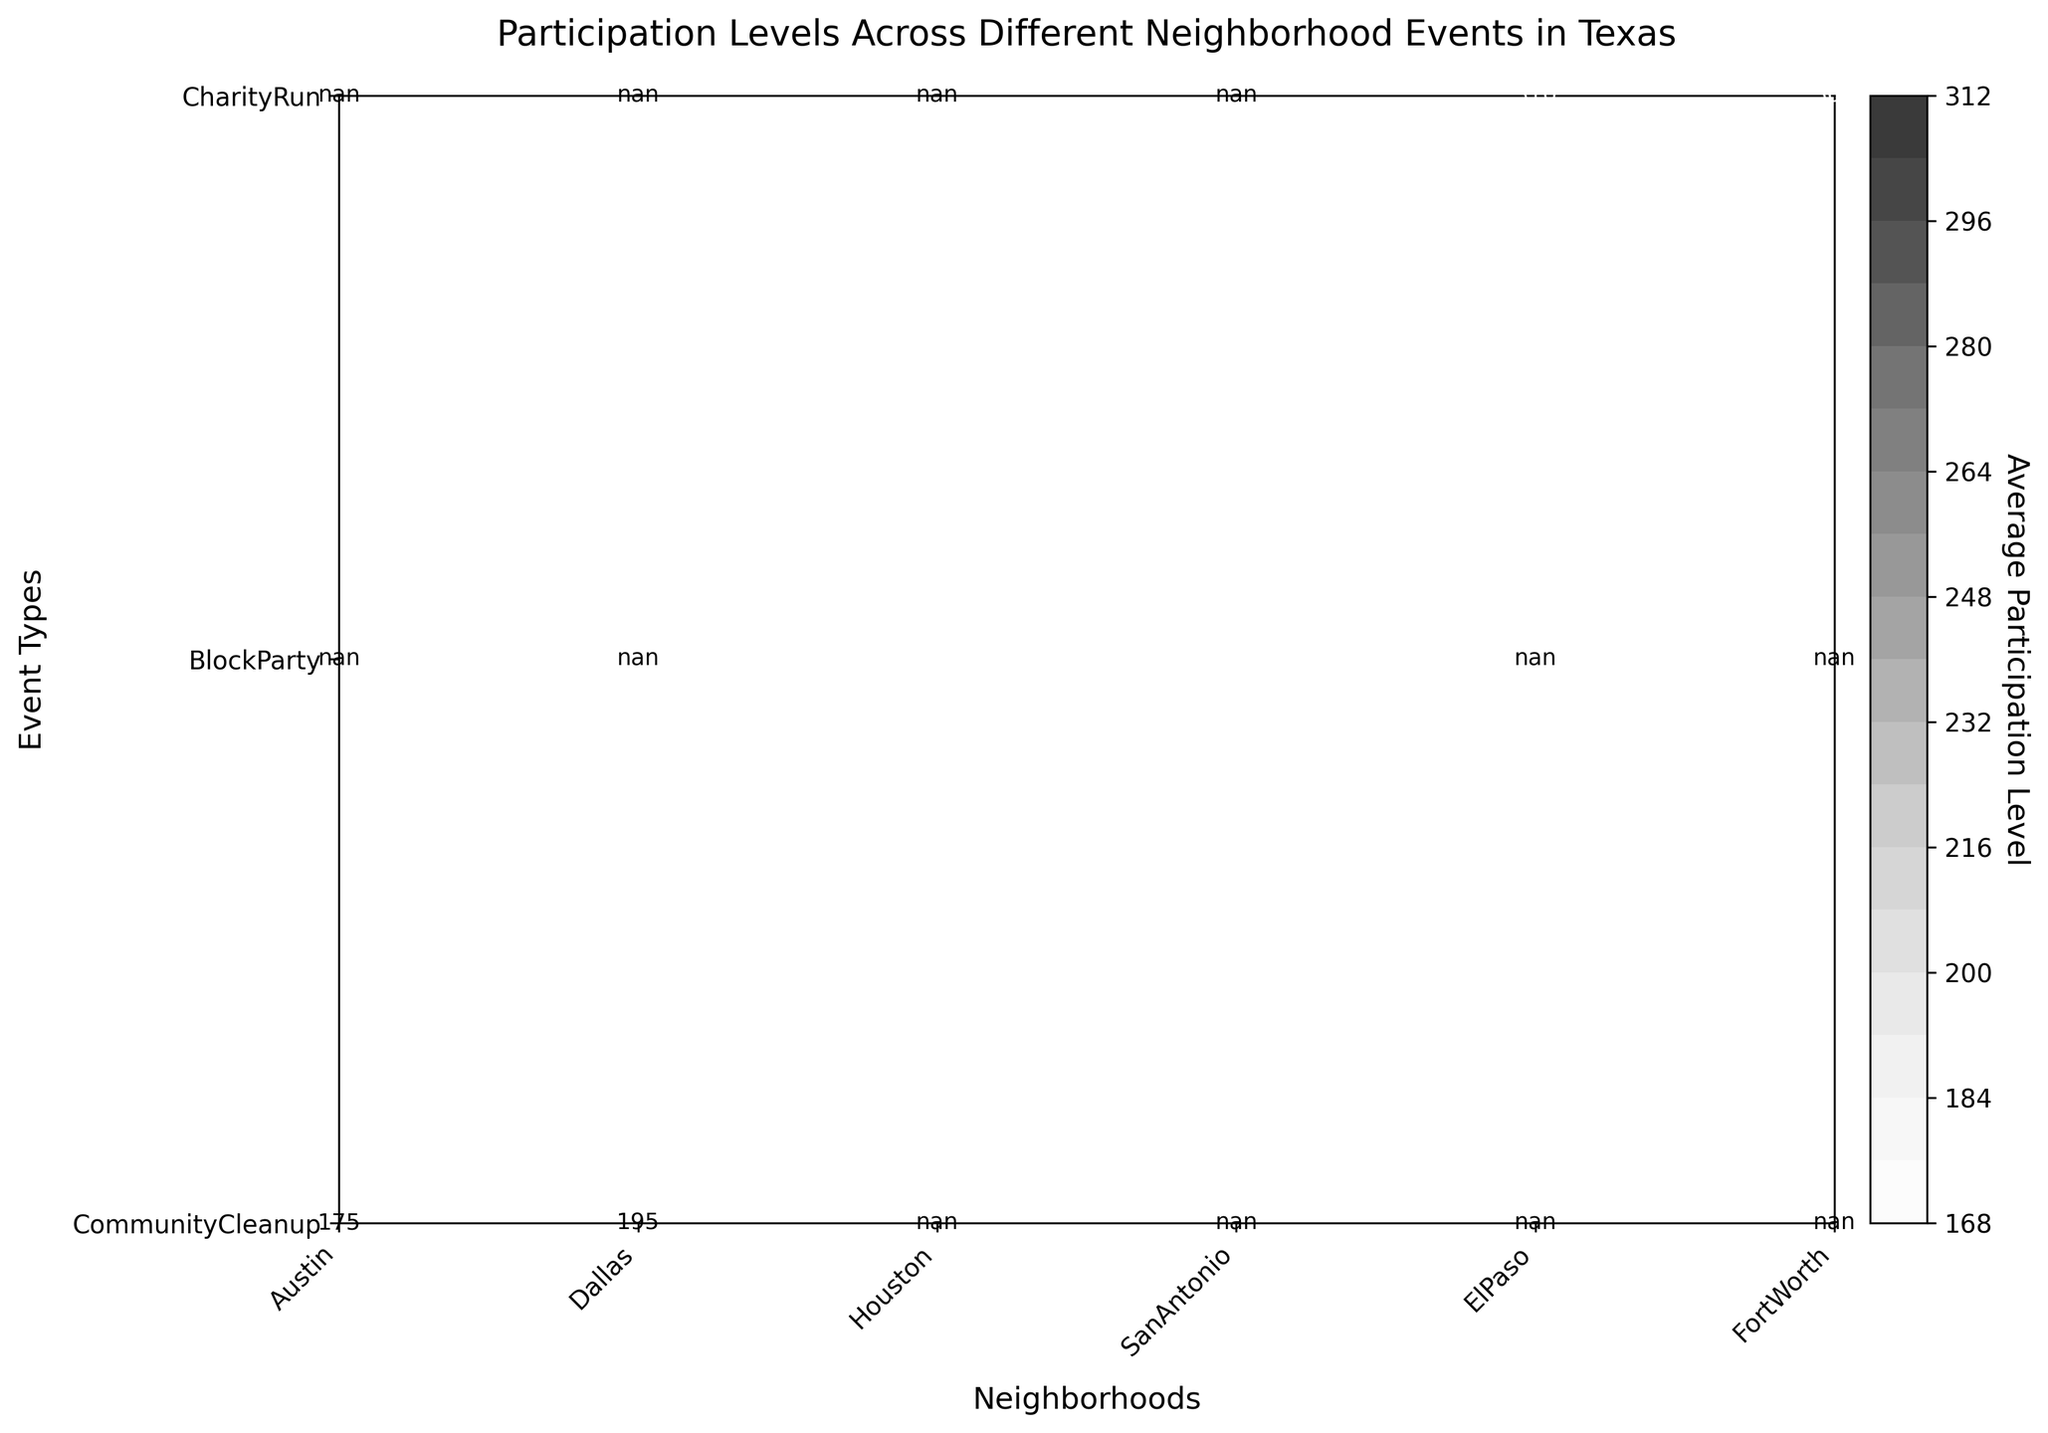What is the title of the figure? The title is usually located at the top center of the plot, indicating what the data represents. In this case, it reads "Participation Levels Across Different Neighborhood Events in Texas".
Answer: Participation Levels Across Different Neighborhood Events in Texas How many neighborhoods are displayed in the figure? The X-axis of the plot represents different neighborhoods. Counting the tick labels along the X-axis will give the number of neighborhoods.
Answer: 6 Which neighborhood has the highest average participation level in the Block Party events? To find the highest average participation level for Block Party events, look at the corresponding row for Block Party and identify the neighborhood column with the highest value.
Answer: Houston Compare the participation levels of Community Cleanup events in Austin and Dallas in June. Which one is higher? Locate the Community Cleanup event type row and then compare the values for Austin and Dallas in the June column. Dallas has a higher average participation level.
Answer: Dallas What is the participation level for the Block Party event in San Antonio in April? To find this, locate the Block Party row for San Antonio and check the participation level for April.
Answer: 230 What is the average participation level across all neighborhoods for Charity Run events? Calculate the mean of the participation levels in the Charity Run event row. Sum the values and divide by the number of neighborhoods. (300+320+290+310)/4 = 305
Answer: 305 Which event type has the lowest average participation across all neighborhoods? Compare the average participation levels in each event type row and identify the one with the smallest value.
Answer: Community Cleanup How does the average participation level of Houston in Block Party events compare to that of El Paso in Charity Run events? Look at the values for Houston in the Block Party row and El Paso in the Charity Run row, then compare the numerical values. Houston has 260, and El Paso has 310, so Houston's value is less.
Answer: Less By how much does the participation level of Dallas in Community Cleanup events in June exceed that in March? Find the difference between the participation levels of Dallas in June and March for the Community Cleanup events. 210 - 180 = 30
Answer: 30 In which month does Fort Worth host its Charity Run events, and what is the participation level? Check the row for Charity Run events and follow it to the column for Fort Worth, noticing the month labels and corresponding participation levels.
Answer: May, 290 